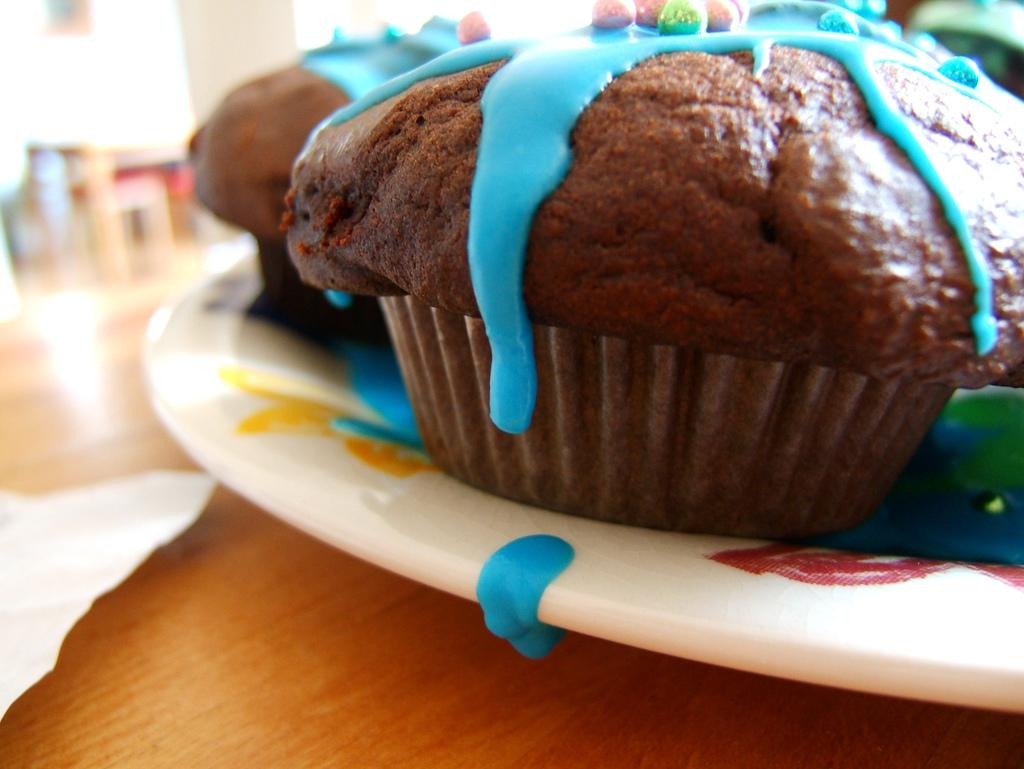What type of food is on the plate in the image? There is a plate of cupcakes in the image. What can be found on the table in addition to the cupcakes? There is a tissue on the table in the image. Can you describe the background of the image? The background of the image is blurred. What type of chain is hanging from the cupcakes in the image? There is no chain hanging from the cupcakes in the image. 